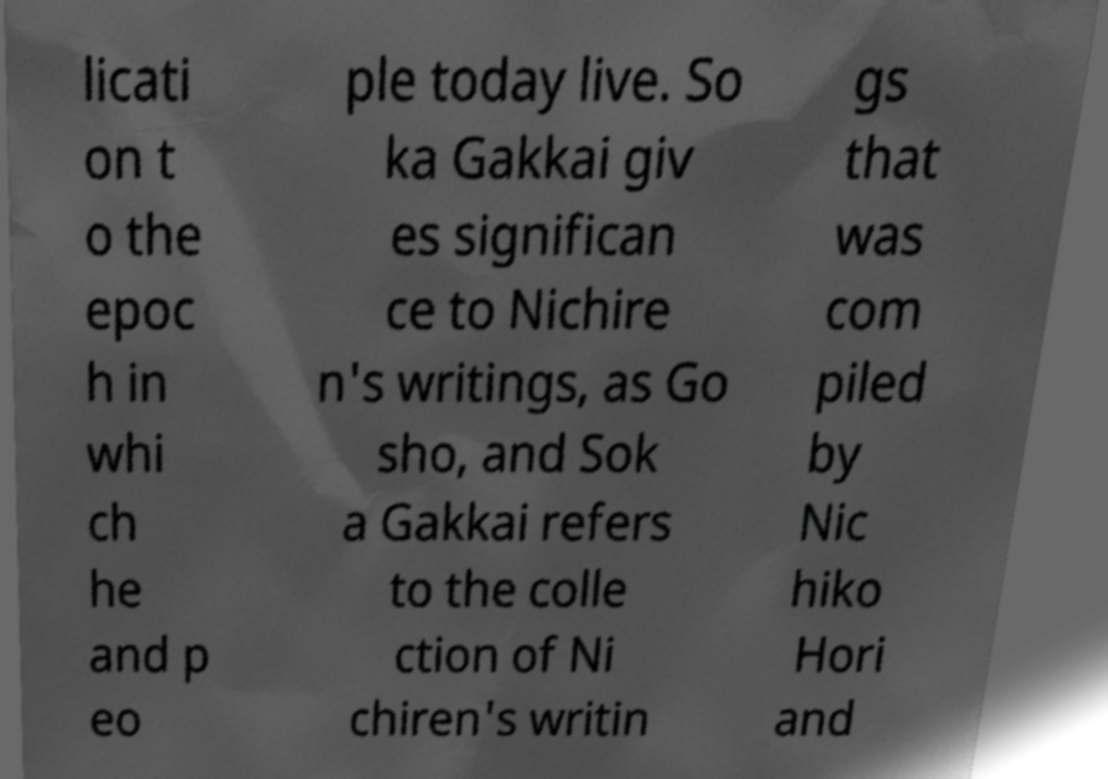Please identify and transcribe the text found in this image. licati on t o the epoc h in whi ch he and p eo ple today live. So ka Gakkai giv es significan ce to Nichire n's writings, as Go sho, and Sok a Gakkai refers to the colle ction of Ni chiren's writin gs that was com piled by Nic hiko Hori and 